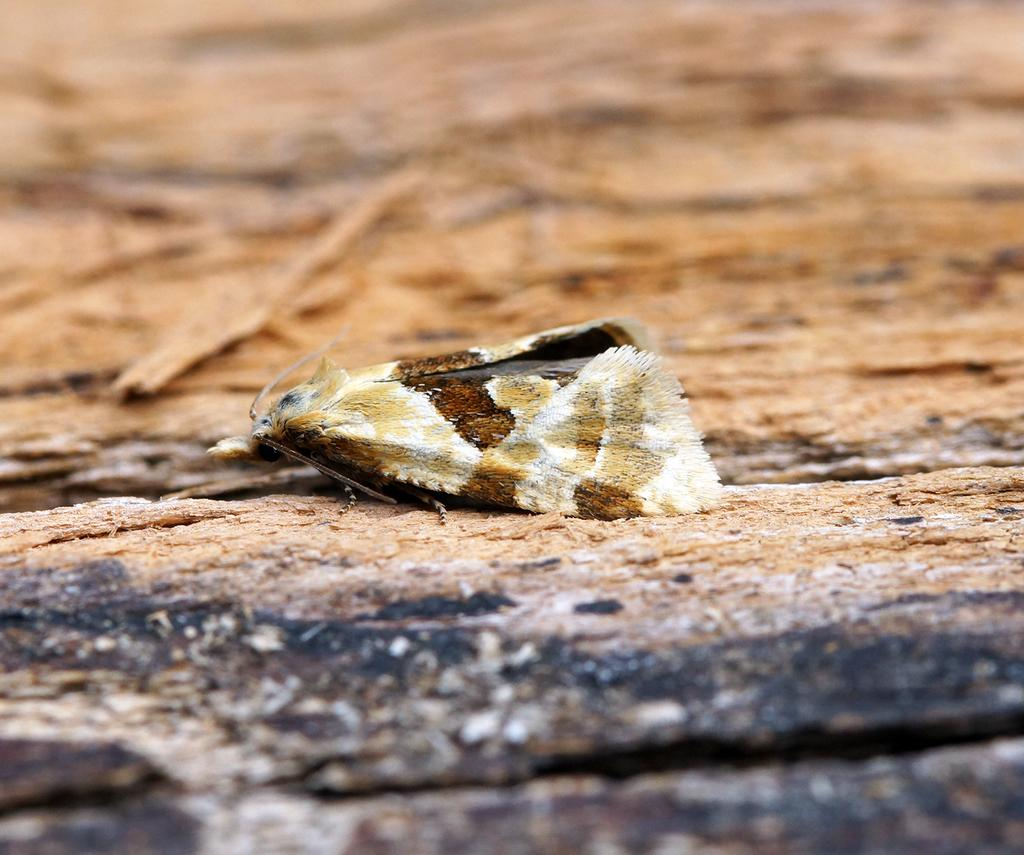What is the main subject of the image? There is a creature in the image. Can you describe the creature's position in the image? The creature is laying on a rock surface. How does the creature talk to its friends in the image? There is no indication in the image that the creature is talking or has friends, as it is simply laying on a rock surface. 